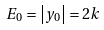<formula> <loc_0><loc_0><loc_500><loc_500>E _ { 0 } = \left | y _ { 0 } \right | = 2 k</formula> 